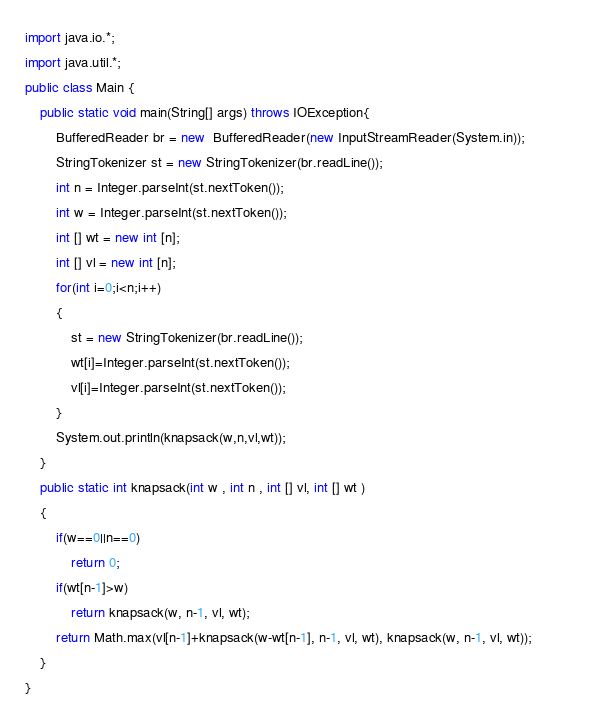Convert code to text. <code><loc_0><loc_0><loc_500><loc_500><_Java_>import java.io.*;
import java.util.*;
public class Main {
	public static void main(String[] args) throws IOException{
		BufferedReader br = new  BufferedReader(new InputStreamReader(System.in));
		StringTokenizer st = new StringTokenizer(br.readLine());
		int n = Integer.parseInt(st.nextToken());
		int w = Integer.parseInt(st.nextToken());
		int [] wt = new int [n];
		int [] vl = new int [n];
		for(int i=0;i<n;i++)
		{
			st = new StringTokenizer(br.readLine());
			wt[i]=Integer.parseInt(st.nextToken());
			vl[i]=Integer.parseInt(st.nextToken());
		}
		System.out.println(knapsack(w,n,vl,wt));
	}
	public static int knapsack(int w , int n , int [] vl, int [] wt )
	{
		if(w==0||n==0)
			return 0;
		if(wt[n-1]>w)
			return knapsack(w, n-1, vl, wt);
		return Math.max(vl[n-1]+knapsack(w-wt[n-1], n-1, vl, wt), knapsack(w, n-1, vl, wt));			
	}
}
</code> 